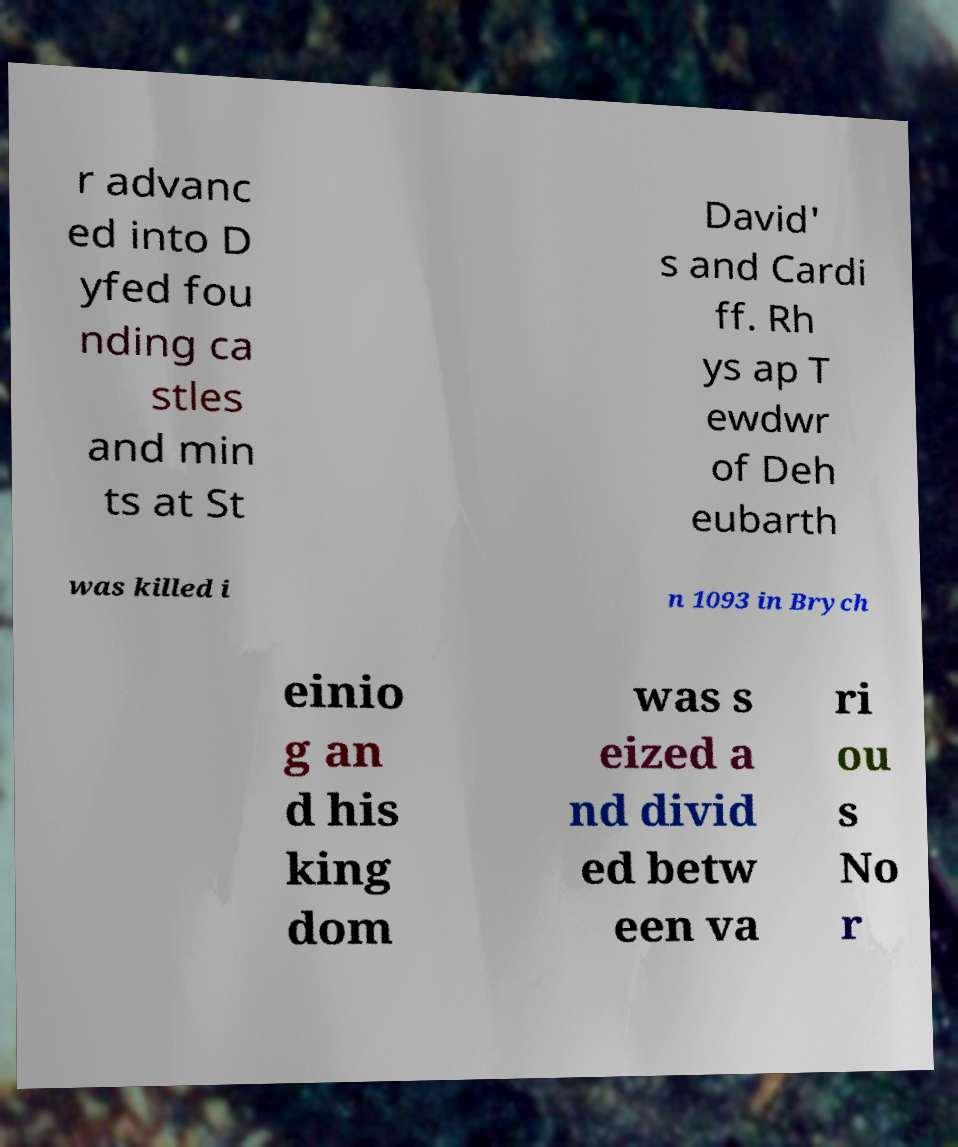What messages or text are displayed in this image? I need them in a readable, typed format. r advanc ed into D yfed fou nding ca stles and min ts at St David' s and Cardi ff. Rh ys ap T ewdwr of Deh eubarth was killed i n 1093 in Brych einio g an d his king dom was s eized a nd divid ed betw een va ri ou s No r 